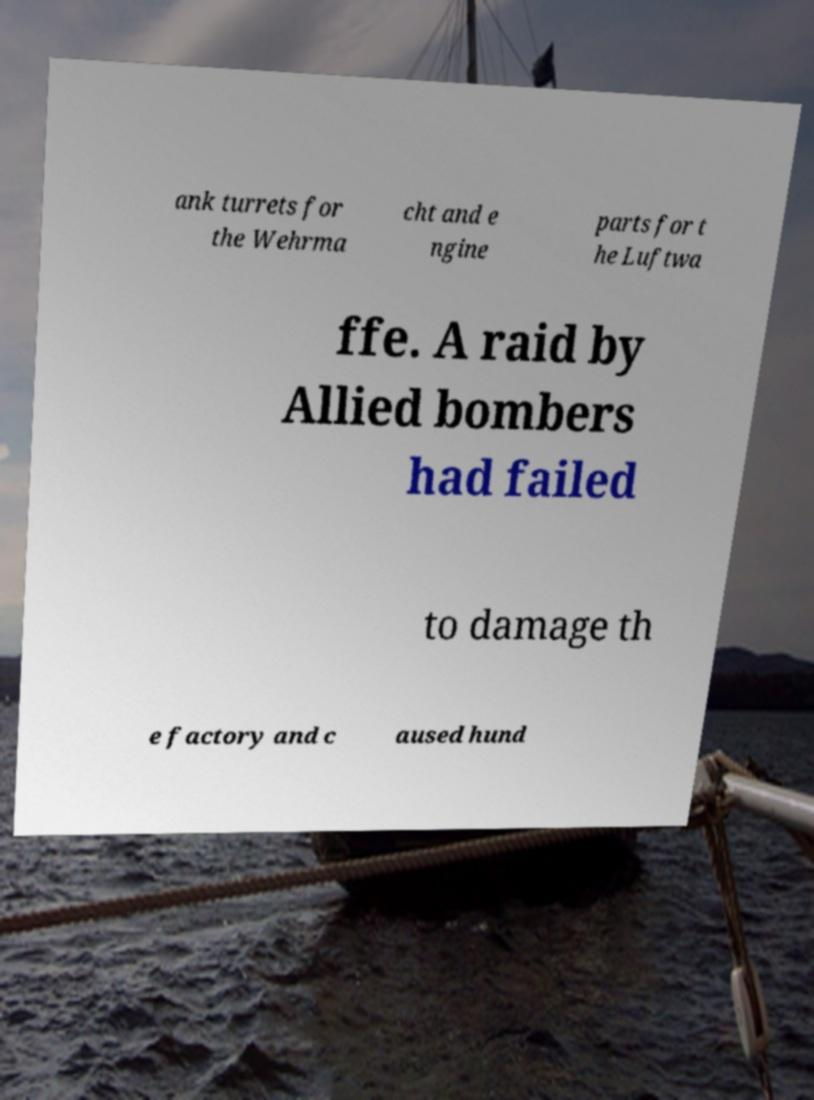Please identify and transcribe the text found in this image. ank turrets for the Wehrma cht and e ngine parts for t he Luftwa ffe. A raid by Allied bombers had failed to damage th e factory and c aused hund 